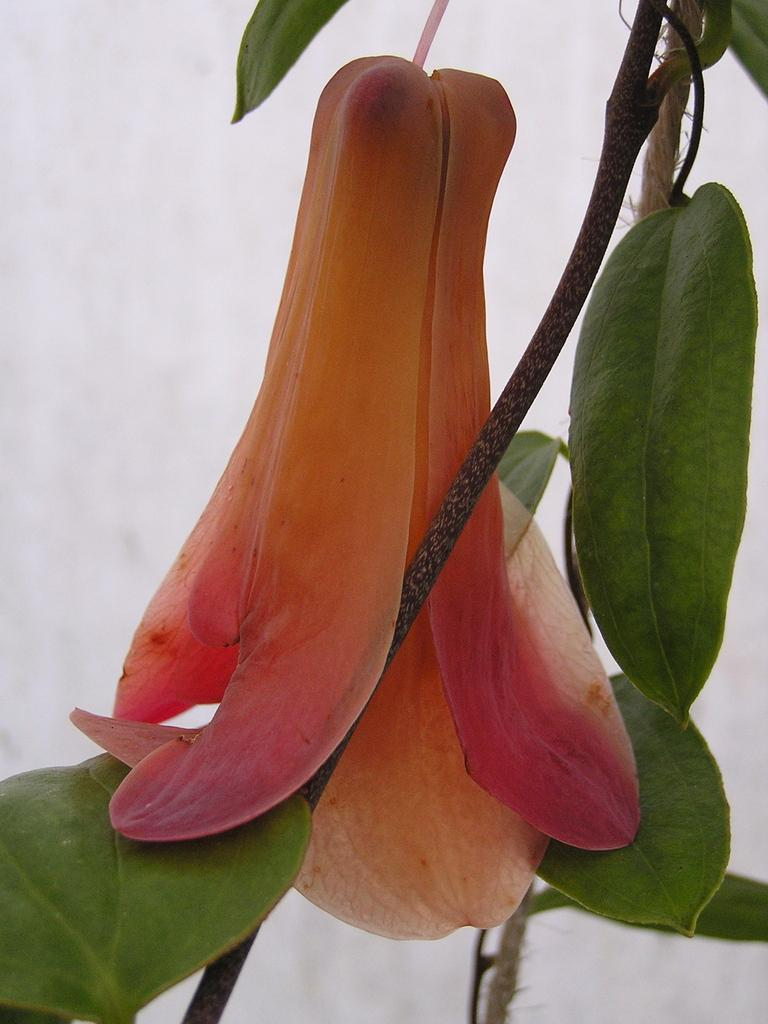What type of plant can be seen in the image? There is a flower in the image. What part of the flower is visible in the image? There is a stem in the image. What other parts of the plant are visible in the image? There are leaves in the image. Can you describe the background of the image? The background of the image is not clear. What type of reaction does the flower have to the magic performed by the bears in the image? There are no bears or magic present in the image, so it is not possible to answer that question. 